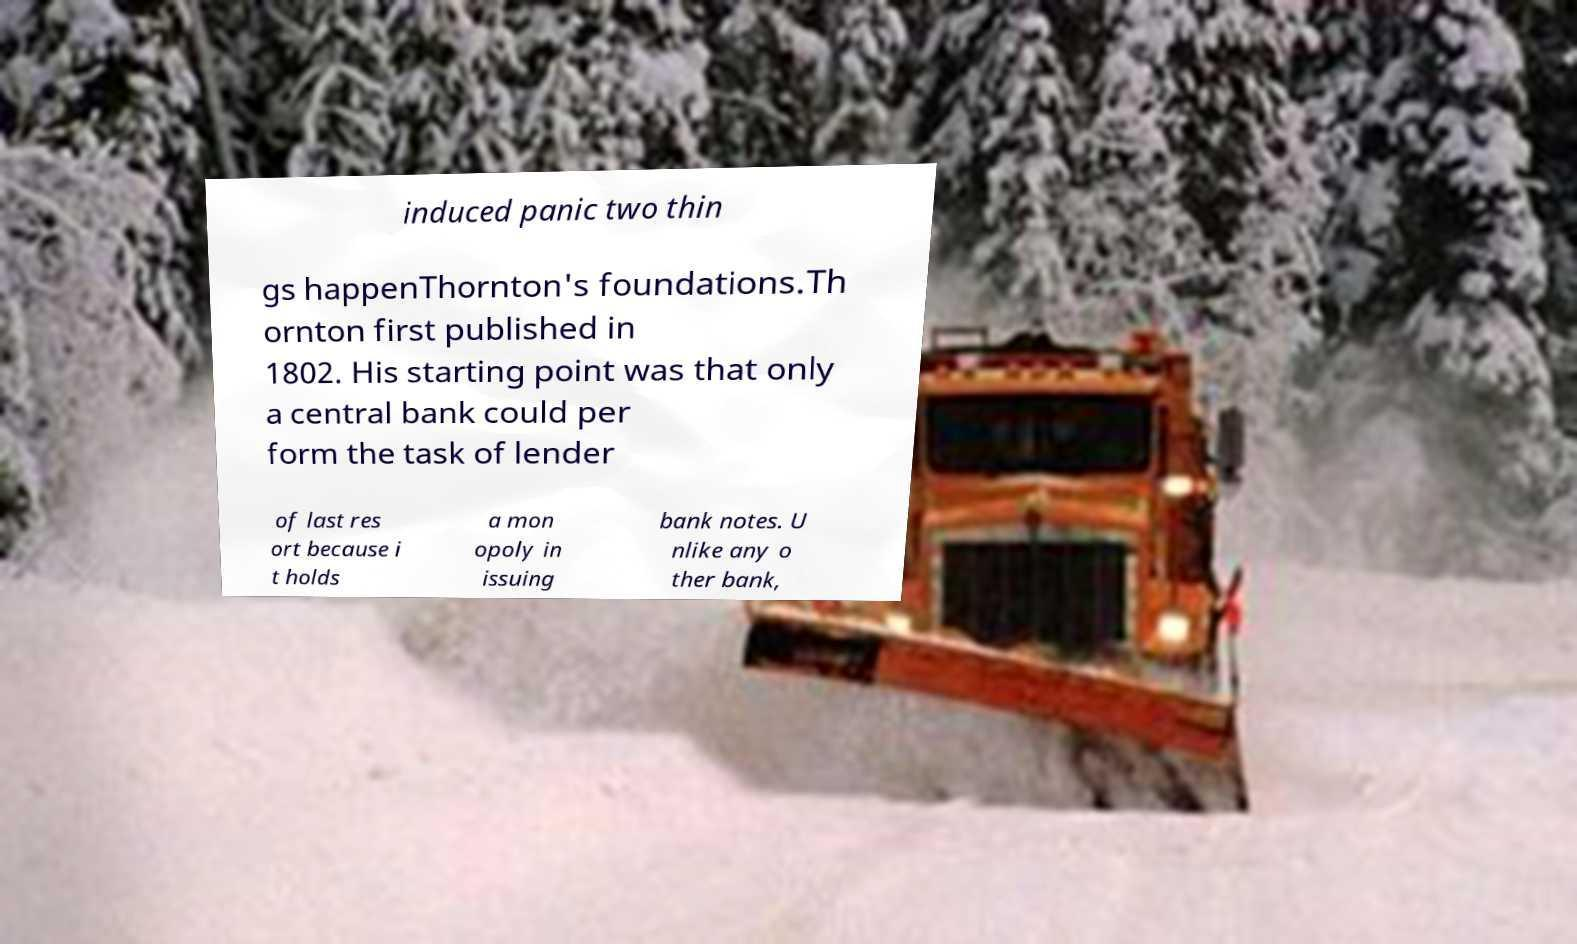There's text embedded in this image that I need extracted. Can you transcribe it verbatim? induced panic two thin gs happenThornton's foundations.Th ornton first published in 1802. His starting point was that only a central bank could per form the task of lender of last res ort because i t holds a mon opoly in issuing bank notes. U nlike any o ther bank, 